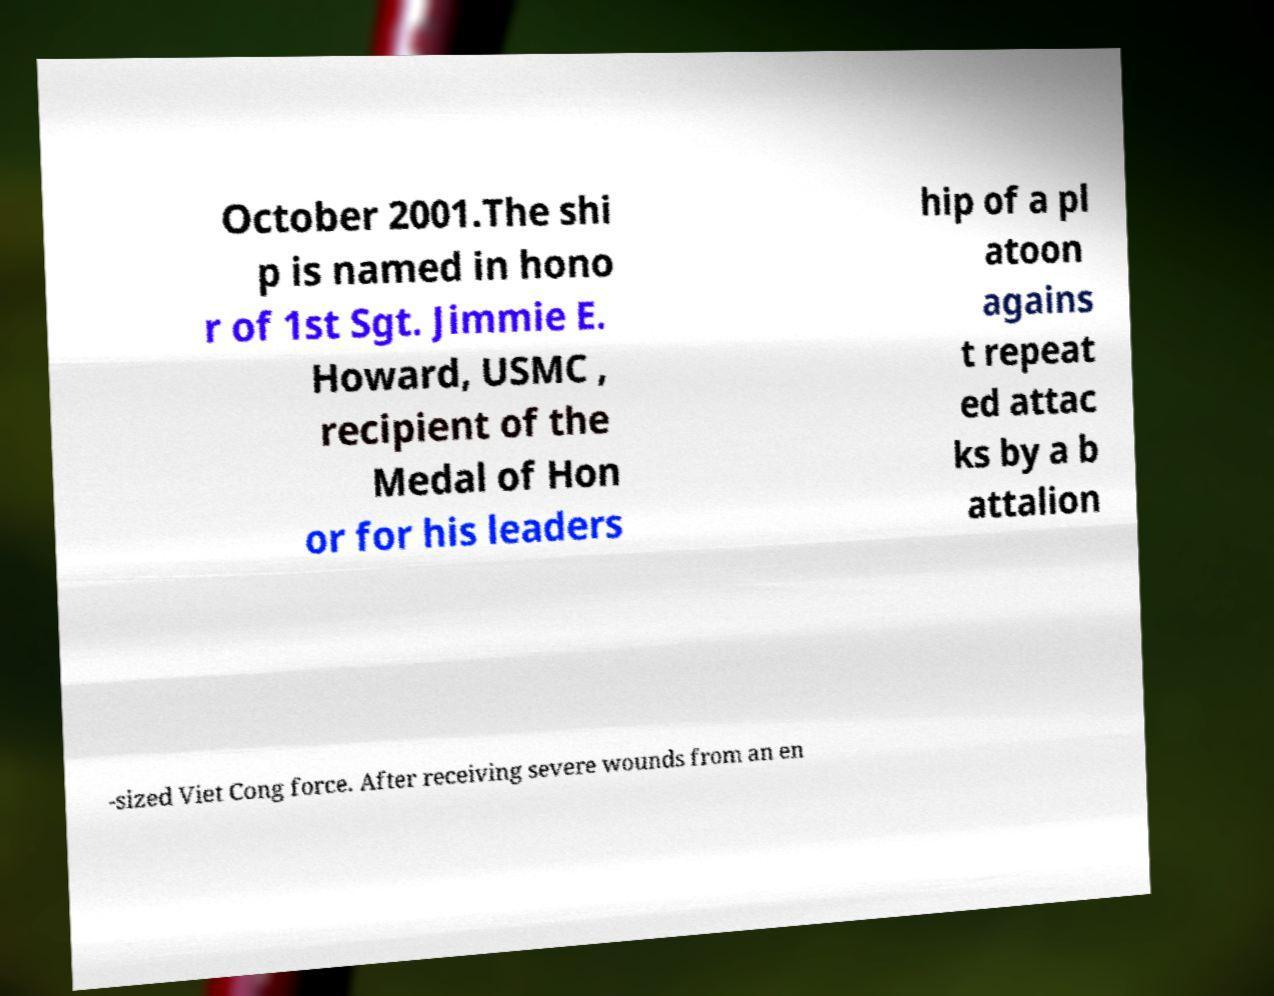For documentation purposes, I need the text within this image transcribed. Could you provide that? October 2001.The shi p is named in hono r of 1st Sgt. Jimmie E. Howard, USMC , recipient of the Medal of Hon or for his leaders hip of a pl atoon agains t repeat ed attac ks by a b attalion -sized Viet Cong force. After receiving severe wounds from an en 